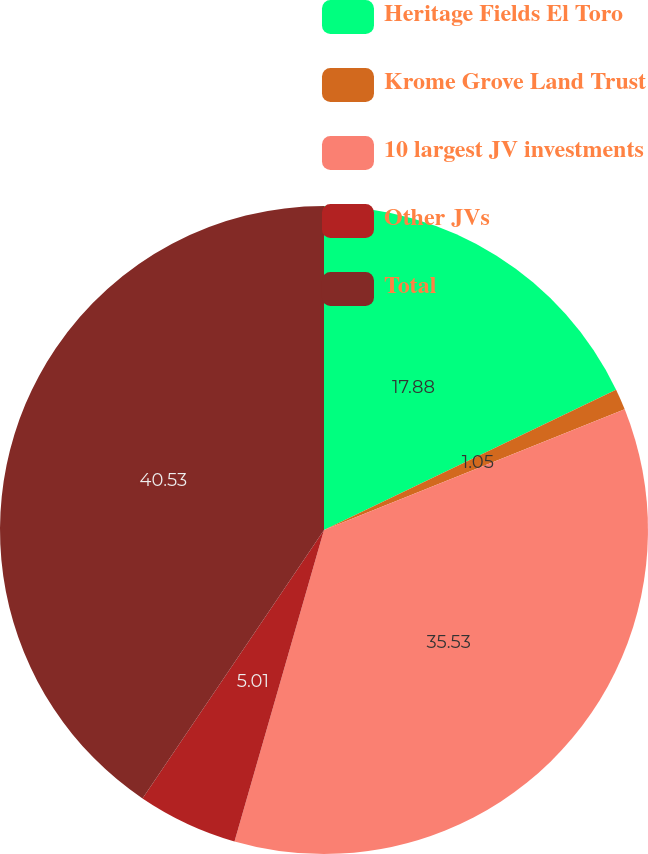Convert chart to OTSL. <chart><loc_0><loc_0><loc_500><loc_500><pie_chart><fcel>Heritage Fields El Toro<fcel>Krome Grove Land Trust<fcel>10 largest JV investments<fcel>Other JVs<fcel>Total<nl><fcel>17.88%<fcel>1.05%<fcel>35.53%<fcel>5.01%<fcel>40.54%<nl></chart> 